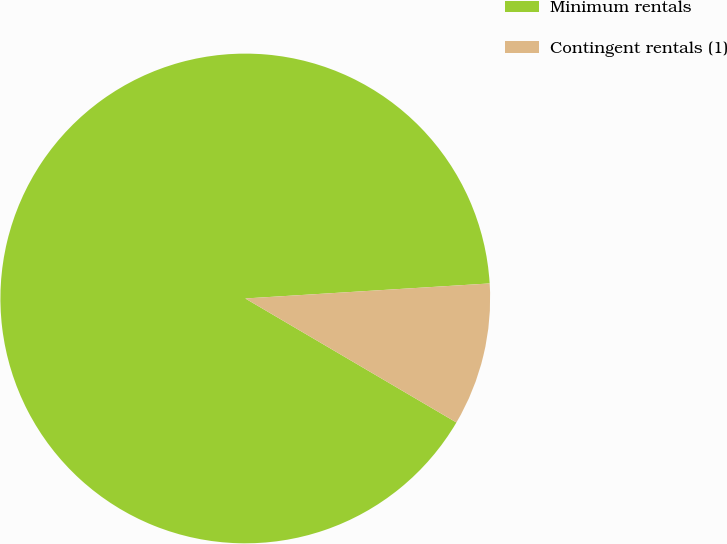<chart> <loc_0><loc_0><loc_500><loc_500><pie_chart><fcel>Minimum rentals<fcel>Contingent rentals (1)<nl><fcel>90.57%<fcel>9.43%<nl></chart> 